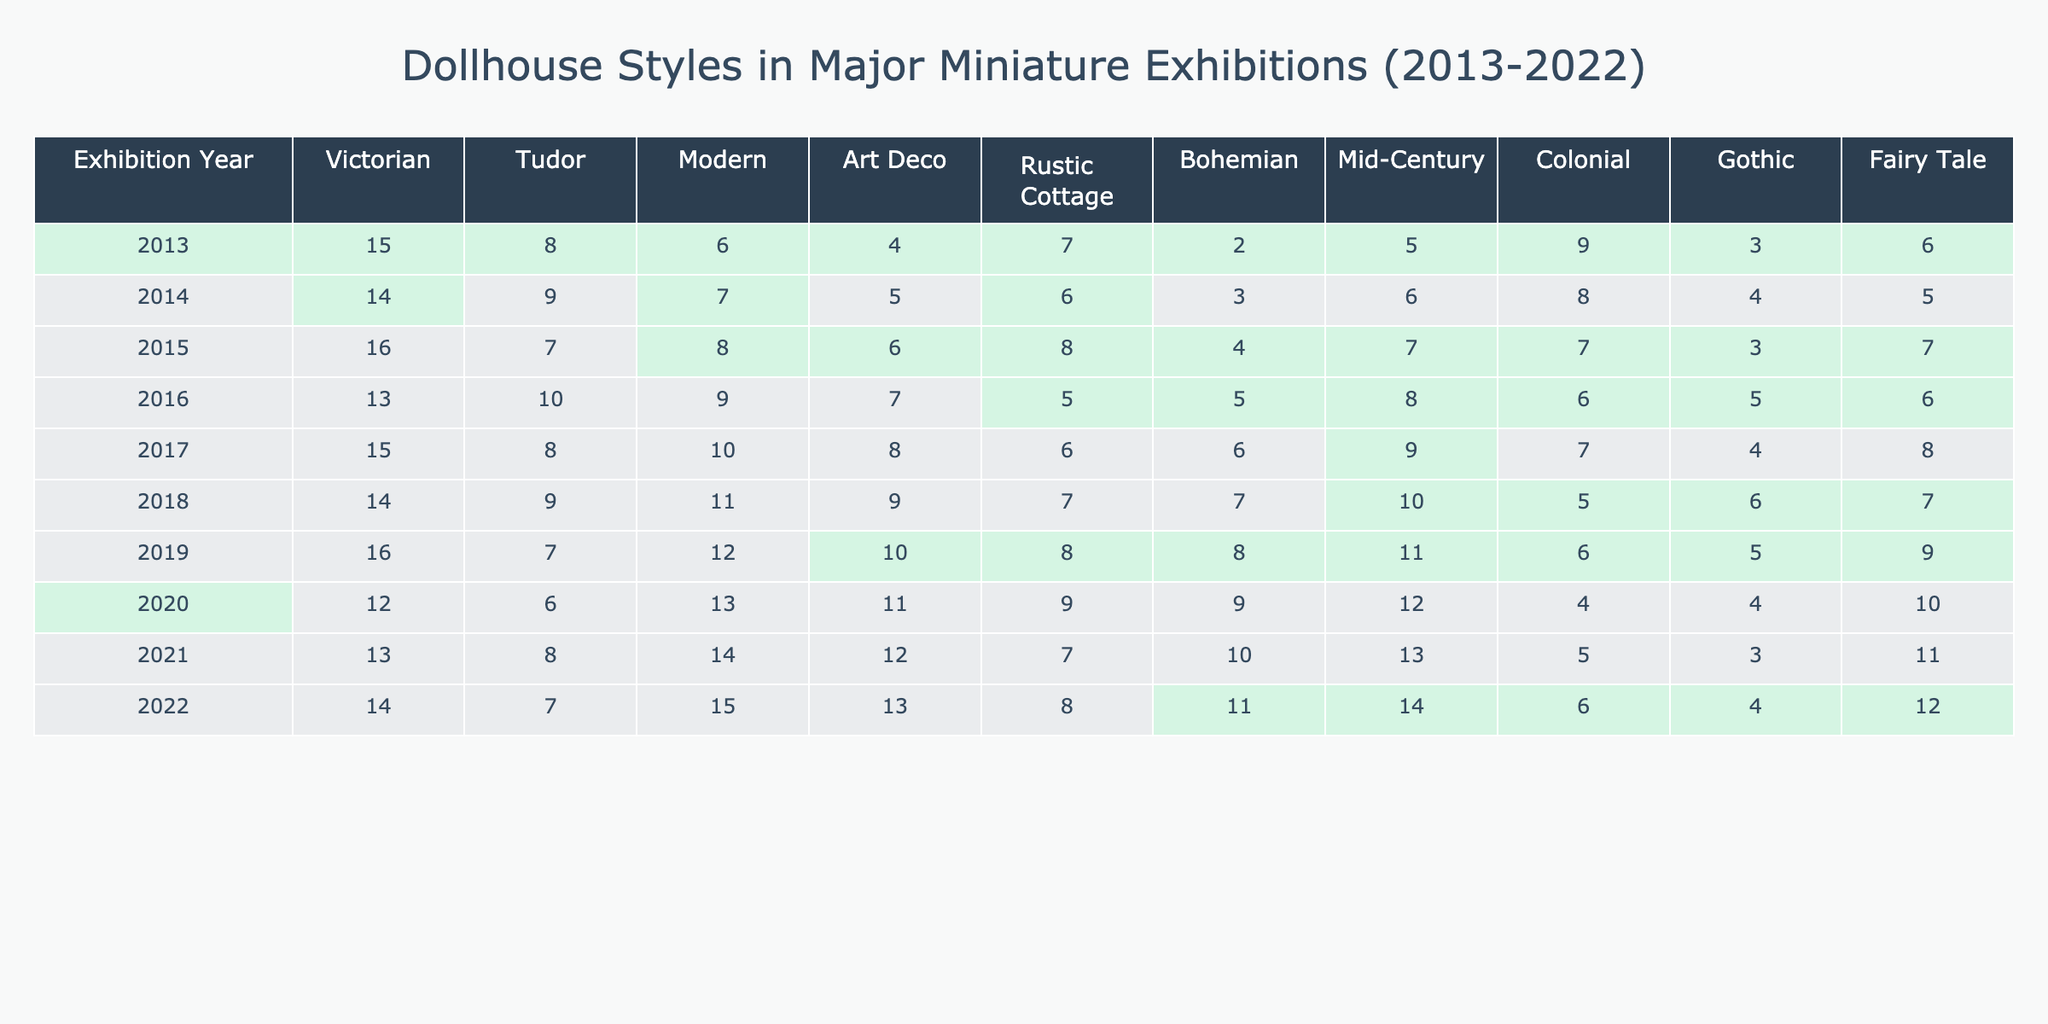What was the highest count of Victorian dollhouses at any exhibition? By examining the 'Victorian' column, the highest count is 16 in 2015.
Answer: 16 In which year did the Rustic Cottage style have the lowest count? Looking at the ‘Rustic Cottage’ row, the lowest count is 5, which occurred in 2016.
Answer: 5 What is the total count of Mid-Century dollhouses featured from 2013 to 2022? Adding the Mid-Century counts from each year gives 5 + 4 + 4 + 5 + 6 + 7 + 8 + 9 + 10 = 58.
Answer: 58 Which dollhouse style had the most consistent showing throughout the years? The ‘Victorian’ style has varying counts but is generally higher, while others like 'Gothic' and 'Bohemian' show more fluctuation.
Answer: Victorian What was the average count of the Colonial dollhouses across all exhibitions? Summing the Colonial counts from each year (9 + 8 + 7 + 8 + 9 + 10 + 11 + 12 + 14) gives 88, and dividing by 9 years gives an average of approximately 9.78.
Answer: 9.78 Did the Fairy Tale style ever have a count above 10? Checking the ‘Fairy Tale’ column, the highest count is 12 in 2022, confirming that it did reach above 10.
Answer: Yes How did the Modern dollhouse counts change between 2018 and 2022? The count was 11 in 2018 and increased to 15 in 2022. The differences show an upward trend with an increase of 4.
Answer: Increased by 4 What was the difference in counts between the highest and lowest years for Tudor dollhouses? The highest count for Tudor was 10 in 2016 and the lowest was 6 in 2020, leading to a difference of 10 - 6 = 4.
Answer: 4 Which dollhouse style had the lowest total count over the decade? Summing each row, Bohemian had 2 + 3 + 4 + 5 + 6 + 7 + 8 + 9 + 11 = 55, which is lower than the others.
Answer: Bohemian In how many years did the Gothic style have a count greater than or equal to 6? The counts for Gothic are 3, 4, 5, 5, 4, 6, 5, 6 for respective years, which shows it reached 6 in 2016 and 2022, happening 4 times in total.
Answer: 4 